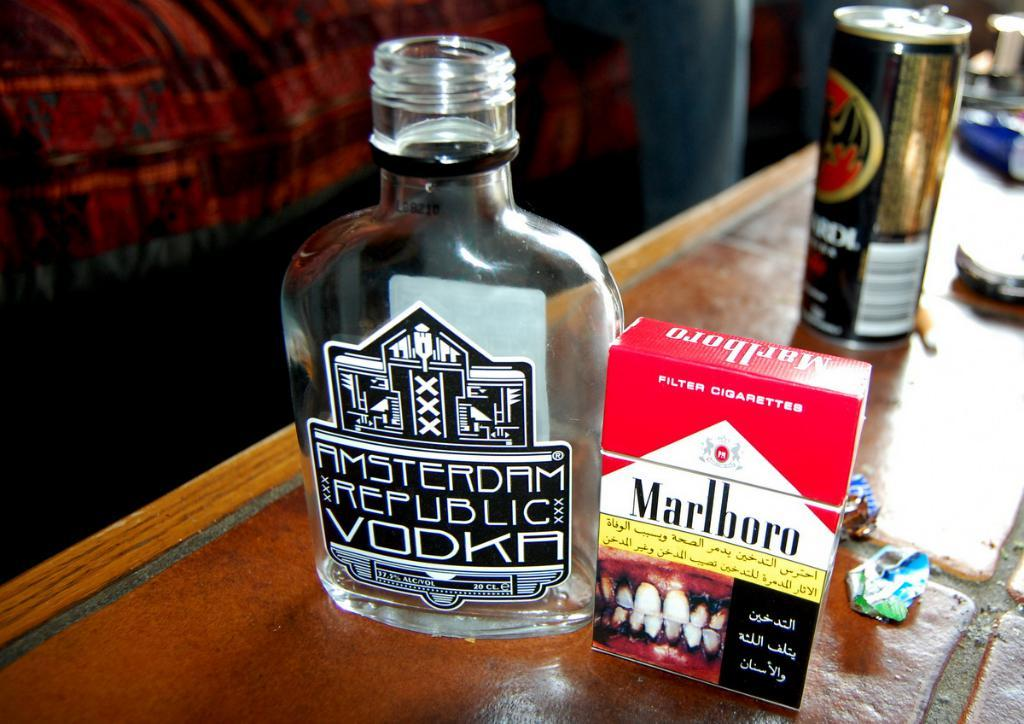<image>
Render a clear and concise summary of the photo. A bottle of Amsterdam Republic Vodka next to a box of Marlboro cigarettes. 